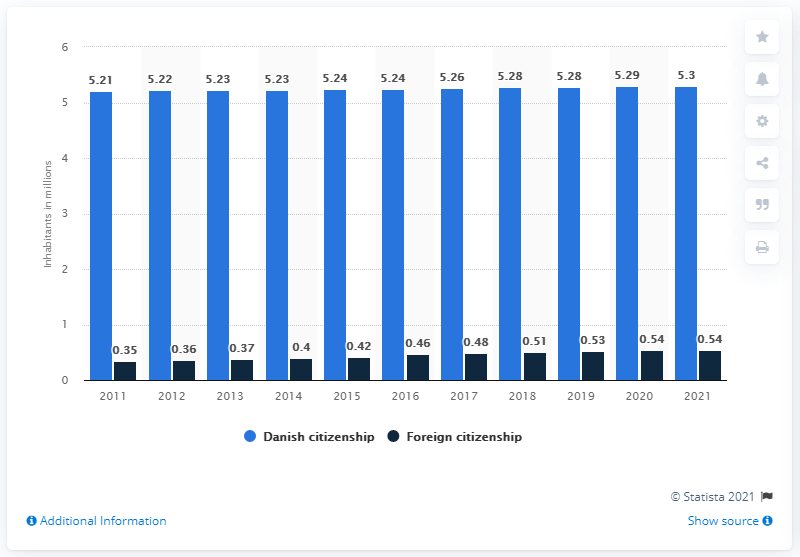Mention a couple of crucial points in this snapshot. As of January 1st, 2021, approximately 0.54% of the population of Denmark had foreign citizenship. 